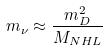Convert formula to latex. <formula><loc_0><loc_0><loc_500><loc_500>m _ { \nu } \approx \frac { m _ { D } ^ { 2 } } { M _ { N H L } }</formula> 